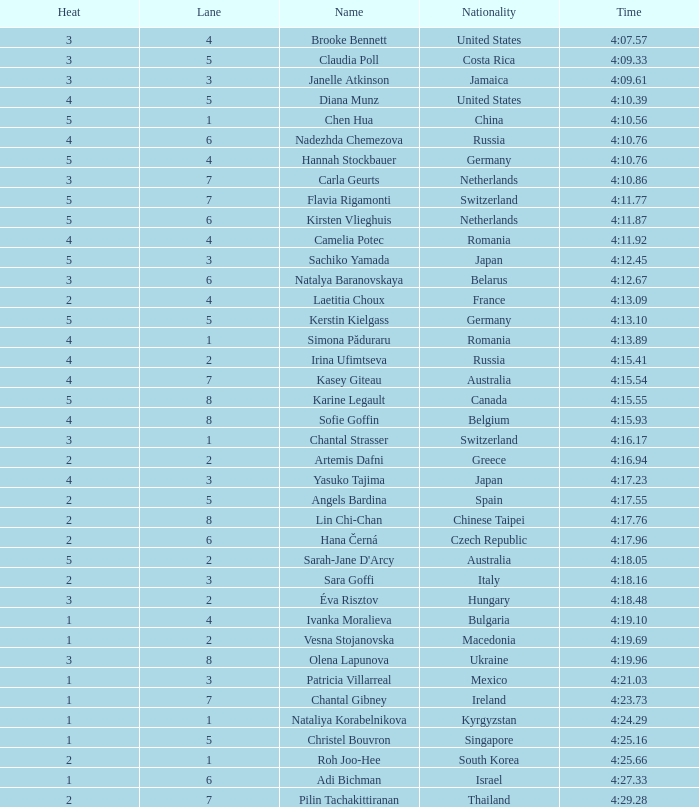Name the average rank with larger than 3 and heat more than 5 None. 